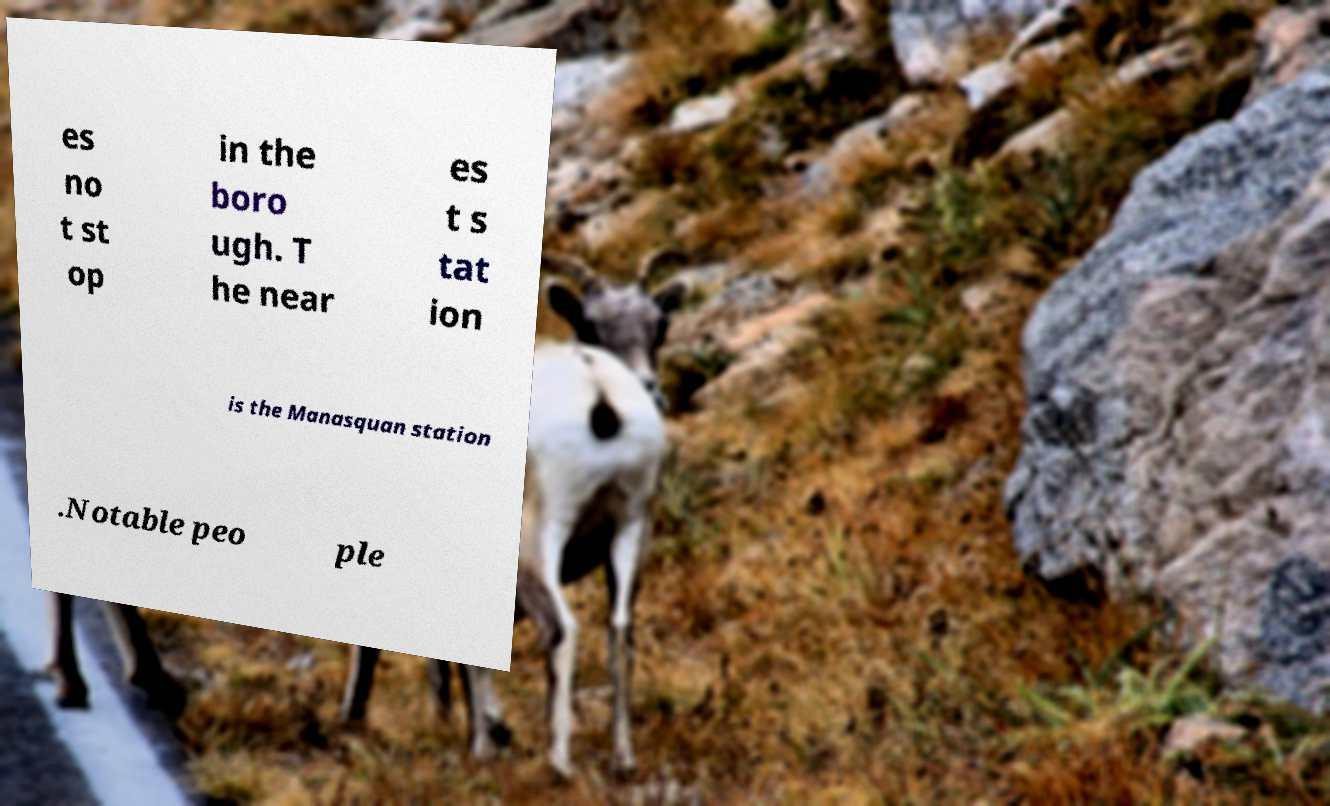Please identify and transcribe the text found in this image. es no t st op in the boro ugh. T he near es t s tat ion is the Manasquan station .Notable peo ple 